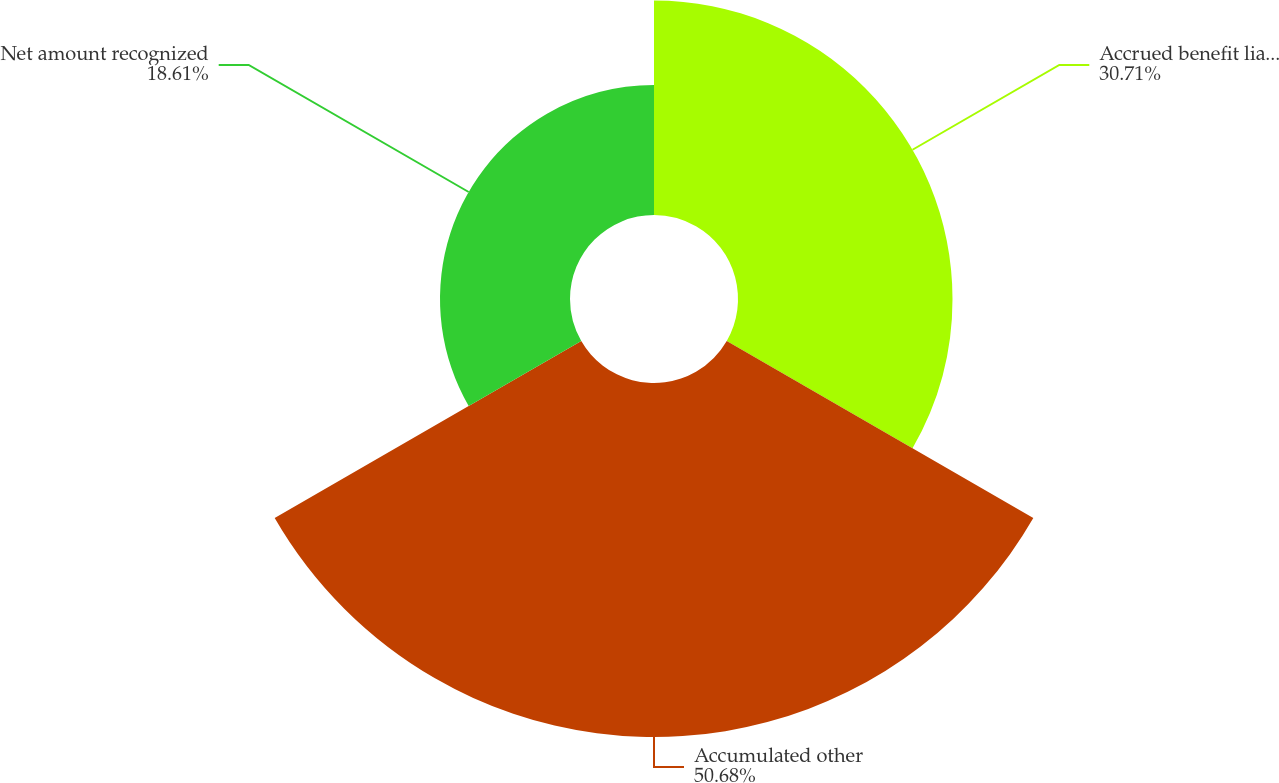Convert chart. <chart><loc_0><loc_0><loc_500><loc_500><pie_chart><fcel>Accrued benefit liability -<fcel>Accumulated other<fcel>Net amount recognized<nl><fcel>30.71%<fcel>50.68%<fcel>18.61%<nl></chart> 